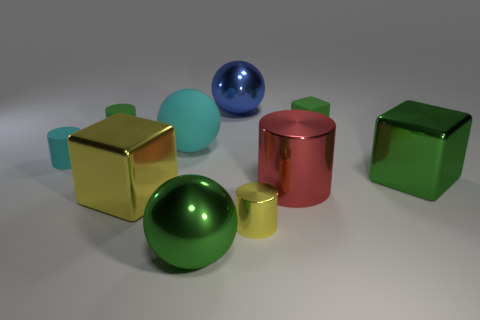Subtract all small cyan cylinders. How many cylinders are left? 3 Subtract all blue cylinders. Subtract all brown balls. How many cylinders are left? 4 Subtract all cylinders. How many objects are left? 6 Subtract all small gray metal spheres. Subtract all large balls. How many objects are left? 7 Add 8 green rubber things. How many green rubber things are left? 10 Add 2 small metal cylinders. How many small metal cylinders exist? 3 Subtract 1 cyan cylinders. How many objects are left? 9 